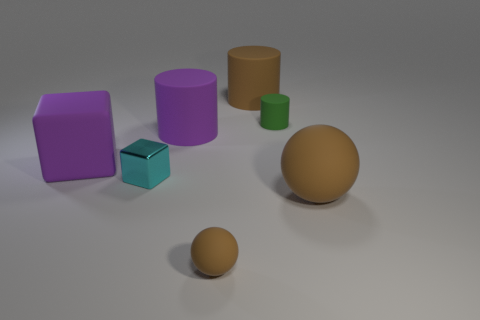Are there the same number of metallic objects that are in front of the big rubber ball and purple matte things?
Your response must be concise. No. The cylinder that is the same color as the tiny matte ball is what size?
Provide a short and direct response. Large. Are there any other brown objects made of the same material as the tiny brown object?
Provide a short and direct response. Yes. Does the green thing that is in front of the brown matte cylinder have the same shape as the big matte thing that is behind the green object?
Make the answer very short. Yes. Is there a green rubber cylinder?
Provide a short and direct response. Yes. What color is the sphere that is the same size as the metal object?
Your answer should be very brief. Brown. How many brown things are the same shape as the green rubber thing?
Give a very brief answer. 1. Is the material of the sphere to the right of the tiny sphere the same as the tiny green cylinder?
Ensure brevity in your answer.  Yes. How many cylinders are either brown rubber things or small brown objects?
Keep it short and to the point. 1. The brown thing in front of the big brown object that is in front of the rubber object behind the small matte cylinder is what shape?
Offer a terse response. Sphere. 